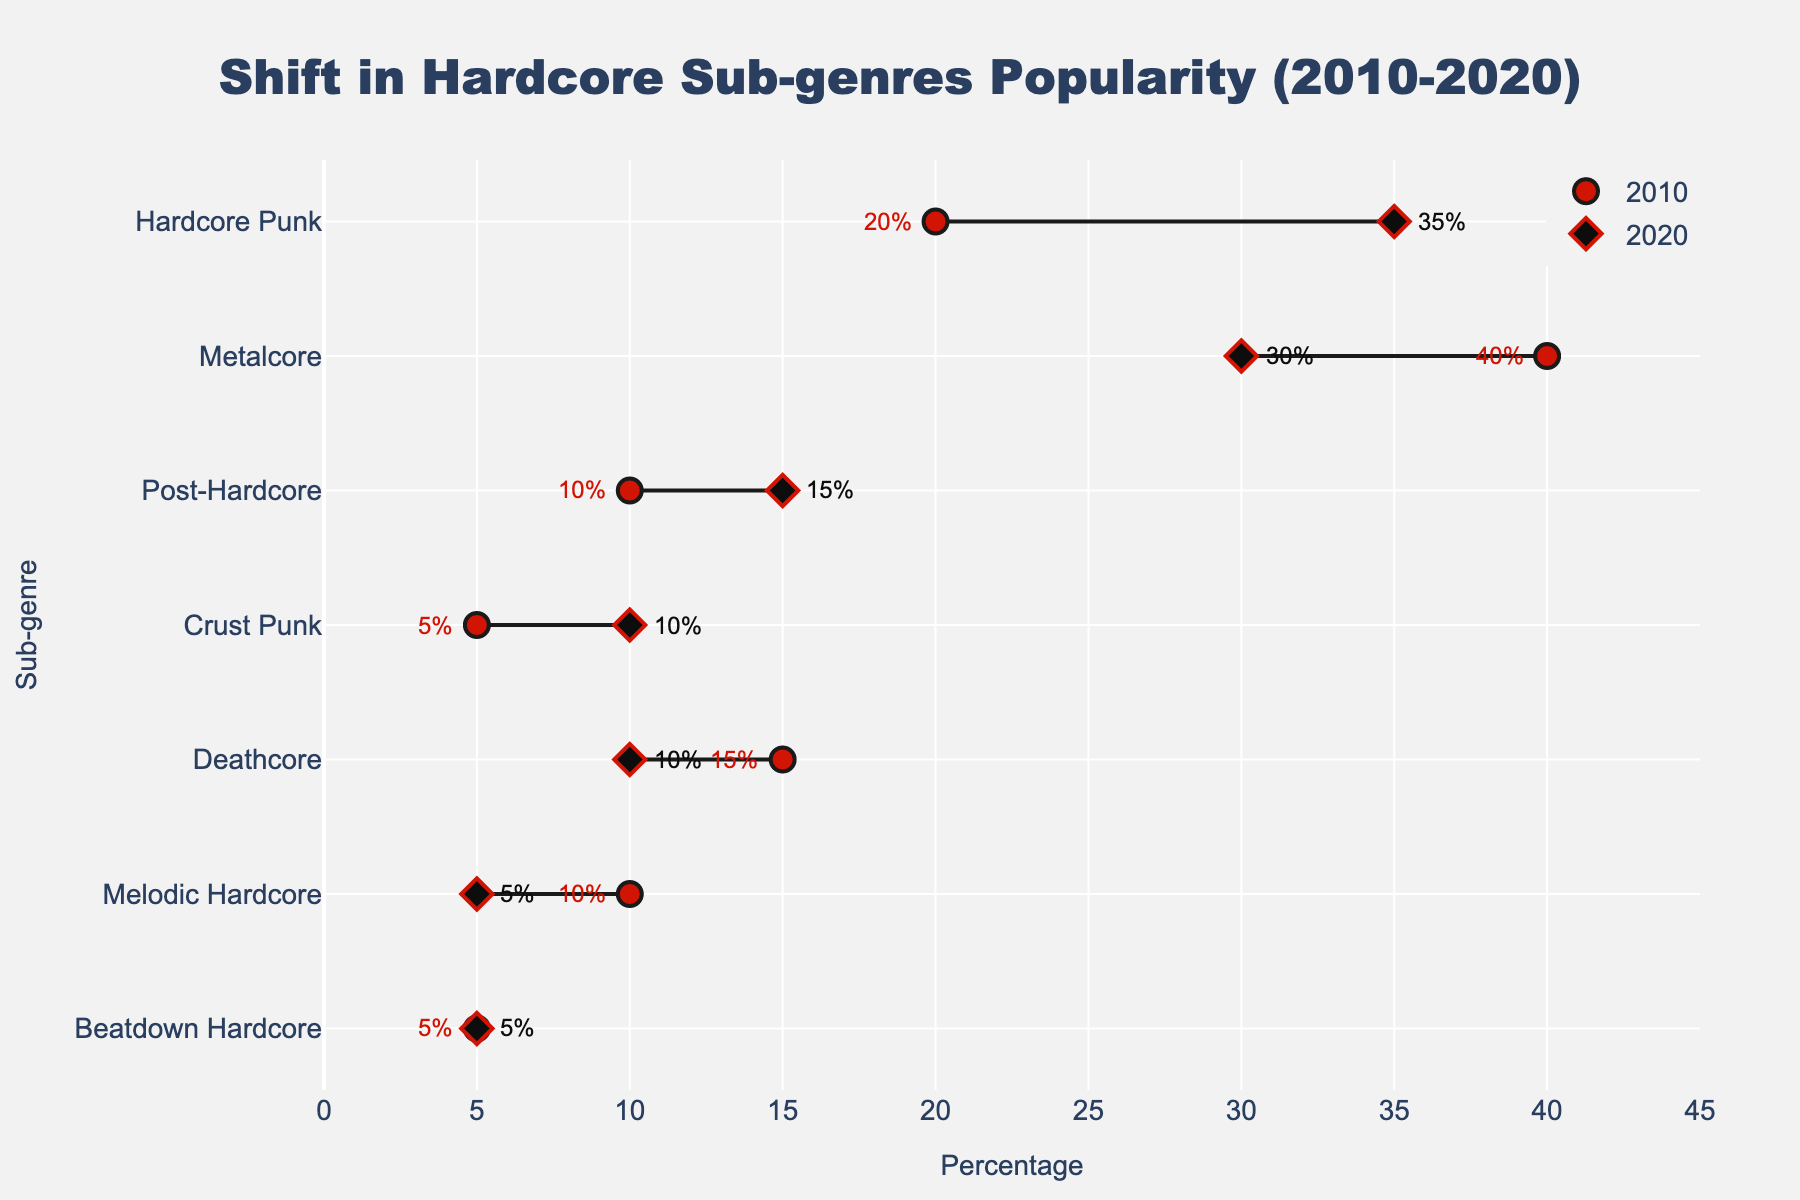How many sub-genres are shown in the figure? Count the number of unique sub-genres listed on the y-axis.
Answer: 7 What is the title of the figure? The title is located at the top center of the figure.
Answer: Shift in Hardcore Sub-genres Popularity (2010-2020) Which sub-genre saw the highest increase in popularity from 2010 to 2020? Compare the difference between the percentage values in 2010 and 2020 for each sub-genre. The highest increase is for Hardcore Punk (from 20% to 35%).
Answer: Hardcore Punk Which sub-genre had the same popularity in both 2010 and 2020? Identify the sub-genre where the percentages for both years are equal.
Answer: Beatdown Hardcore What is the percentage change for Deathcore from 2010 to 2020? Subtract the percentage in 2020 from that in 2010 for Deathcore.
Answer: -5% Which sub-genre decreased the most in popularity from 2010 to 2020? Calculate the percentage decrease for each sub-genre and find the largest decrease.
Answer: Metalcore What is the median percentage of popularity for the sub-genres in 2020? Sort the percentages for 2020 and find the middle value. The sorted values are: 5, 5, 10, 10, 15, 30, 35, hence the median is 10.
Answer: 10% What is the average percentage of popularity for the sub-genres in 2010? Sum the percentages for 2010 and divide by the number of sub-genres. (40 + 20 + 10 + 15 + 5 + 10 + 5) = 105; 105 / 7 = 15
Answer: 15% Which sub-genre had the highest popularity in 2010? Identify the sub-genre with the highest percentage value in 2010.
Answer: Metalcore Which marker color represents the 2020 percentages? Observe the figure for the marker color used for 2020 values.
Answer: Black 